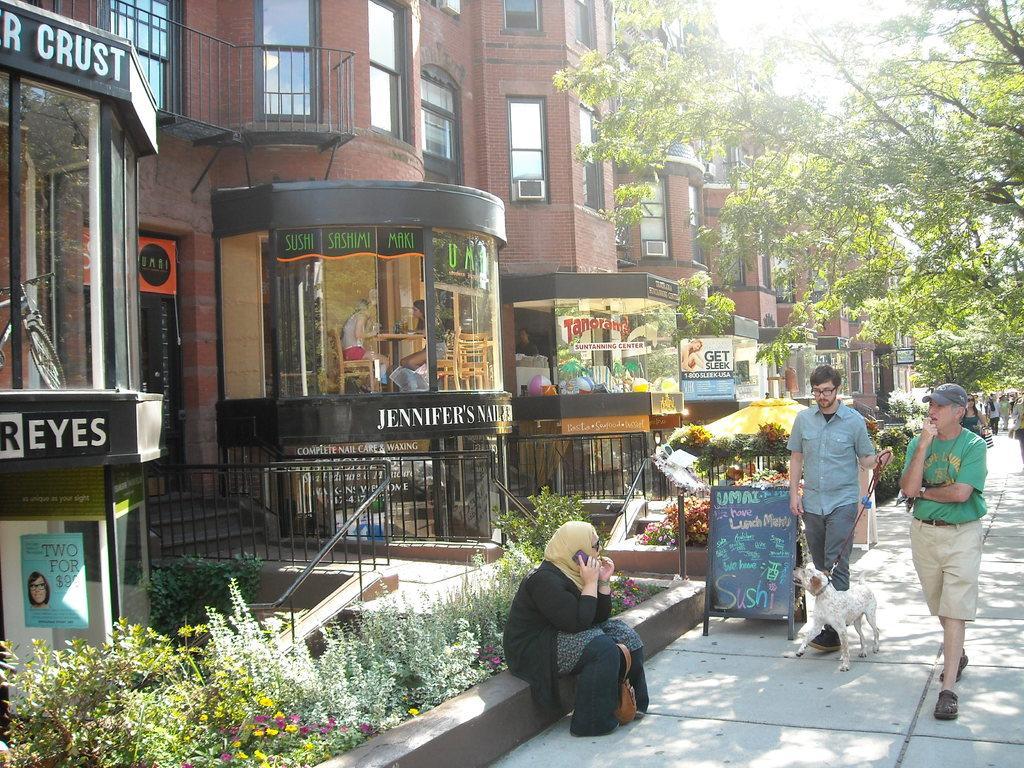Could you give a brief overview of what you see in this image? At the top we can see sky and it seems like a sunny day. These are trees near to the buildings and stores. Here we can see persons standing and walking. Here we can see one woman sitting near to the flower plants.. This is a board. We can see one man holding a dog´s belt in his hand. 